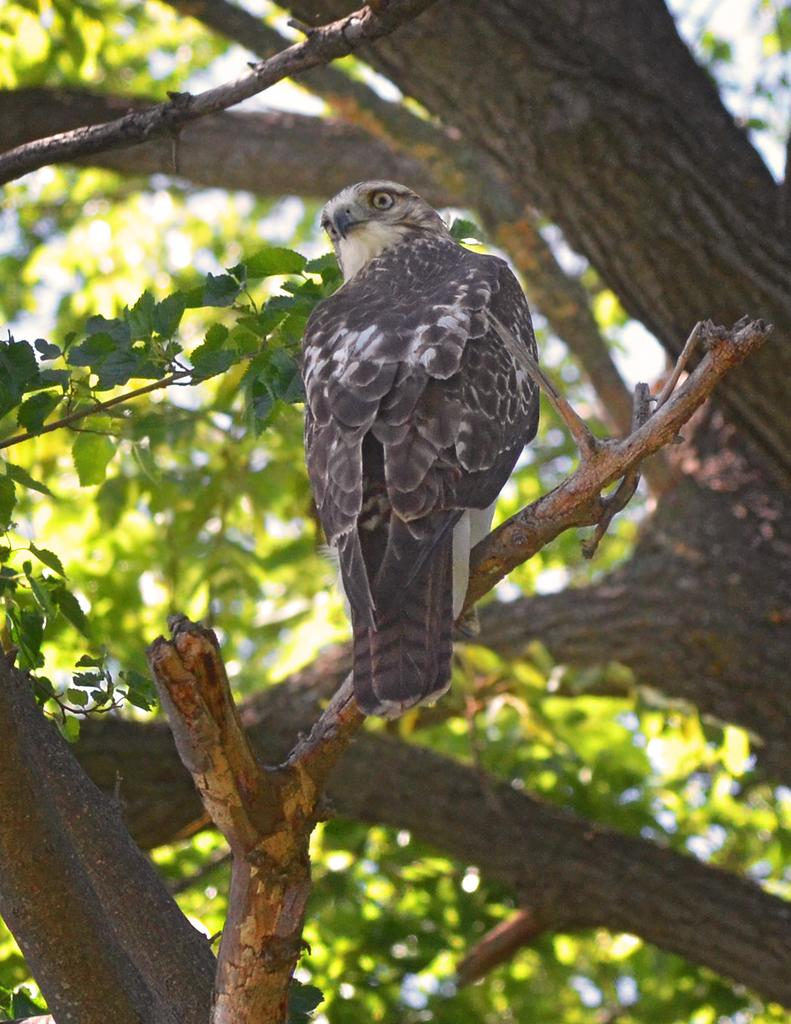What is the main subject of the picture? The main subject of the picture is an eagle. Can you describe the location of the eagle in the picture? The eagle is sitting on the stem of the tree in the picture. What else can be seen in the picture besides the eagle? There is a tree in the picture. What type of breakfast is the eagle eating in the picture? There is no breakfast present in the image, as it features an eagle sitting on a tree. Can you see any geese in the picture? There are no geese present in the image; it only features an eagle and a tree. 